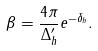Convert formula to latex. <formula><loc_0><loc_0><loc_500><loc_500>\beta = \frac { 4 \pi } { \Delta _ { h } ^ { \prime } } e ^ { - \delta _ { h } } .</formula> 